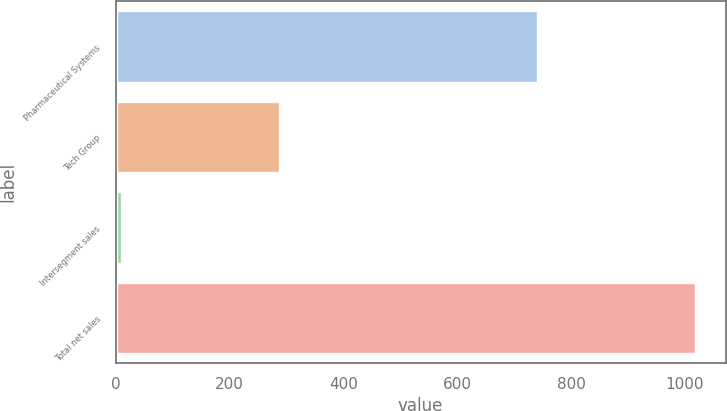Convert chart. <chart><loc_0><loc_0><loc_500><loc_500><bar_chart><fcel>Pharmaceutical Systems<fcel>Tech Group<fcel>Intersegment sales<fcel>Total net sales<nl><fcel>741.8<fcel>289.2<fcel>10.9<fcel>1020.1<nl></chart> 